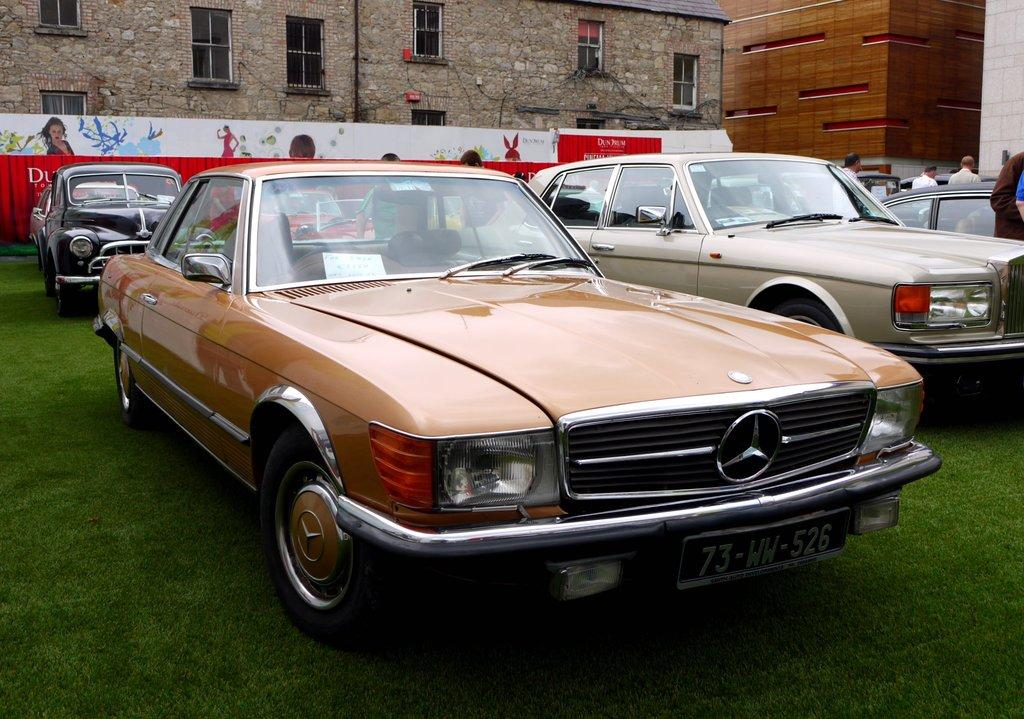What type of vehicles can be seen on the ground in the image? There are cars on the ground in the image. Who or what else can be seen in the image besides the cars? There are people visible in the image. What can be seen in the background of the image? There are hoardings, windows, and buildings visible in the background of the image. What type of comfort can be seen being offered to the root in the image? There is no root present in the image, and therefore no comfort can be offered to it. 